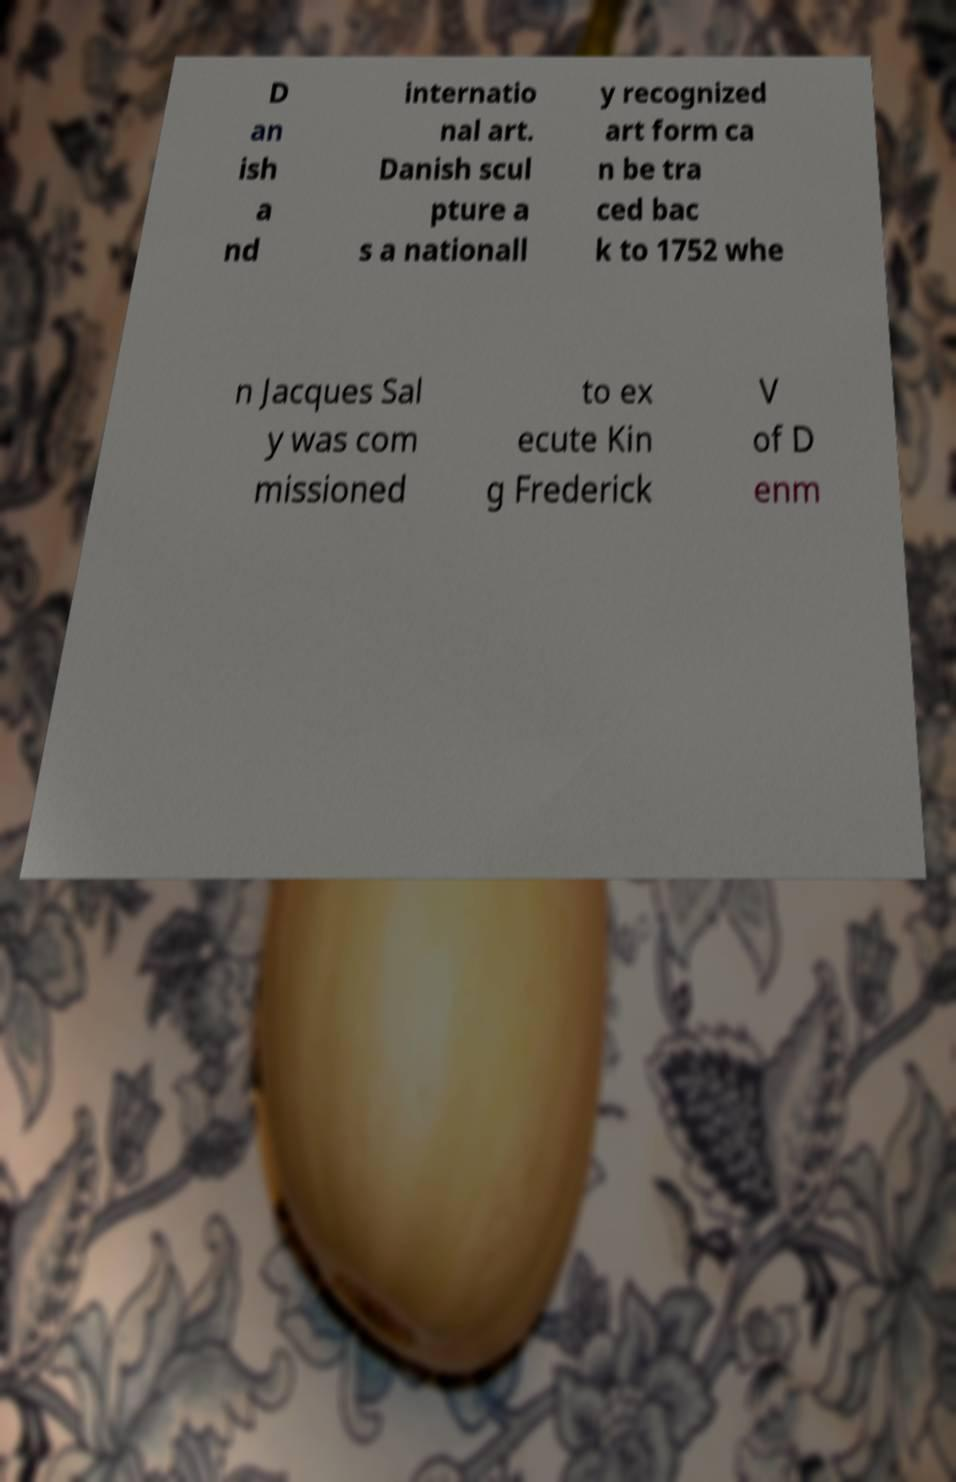I need the written content from this picture converted into text. Can you do that? D an ish a nd internatio nal art. Danish scul pture a s a nationall y recognized art form ca n be tra ced bac k to 1752 whe n Jacques Sal y was com missioned to ex ecute Kin g Frederick V of D enm 